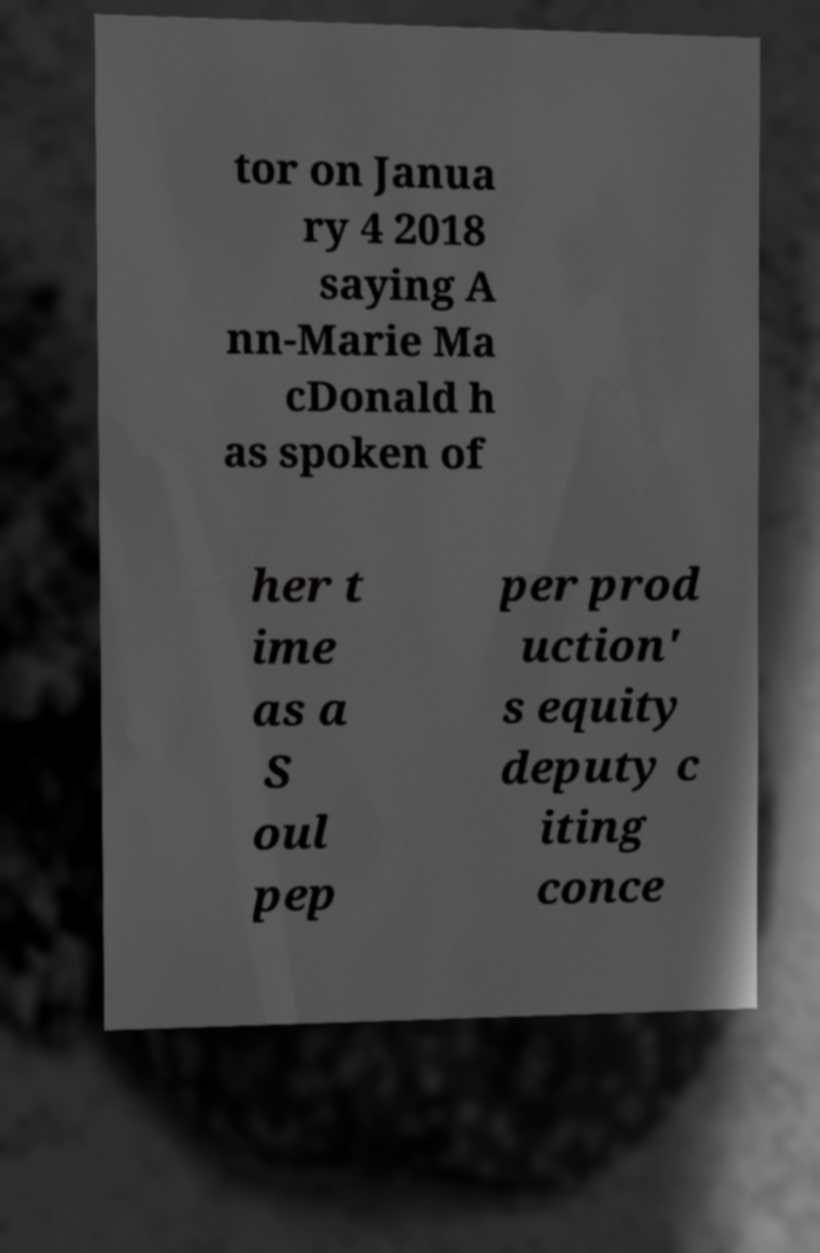For documentation purposes, I need the text within this image transcribed. Could you provide that? tor on Janua ry 4 2018 saying A nn-Marie Ma cDonald h as spoken of her t ime as a S oul pep per prod uction' s equity deputy c iting conce 